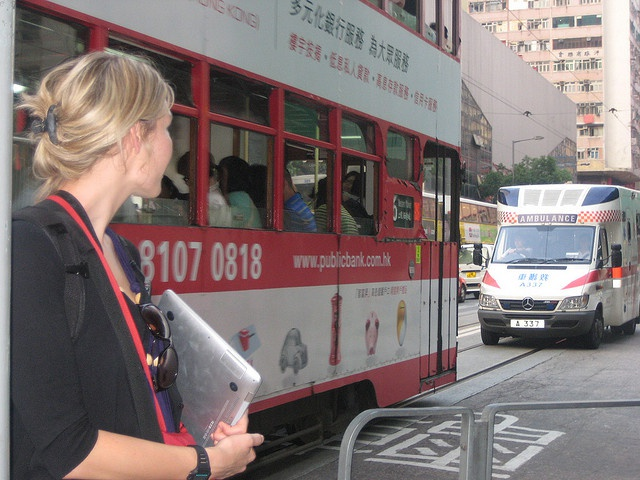Describe the objects in this image and their specific colors. I can see bus in lightgray, darkgray, black, gray, and maroon tones, people in lightgray, black, tan, and gray tones, truck in lightgray, white, darkgray, gray, and black tones, laptop in lightgray, gray, and darkgray tones, and backpack in lightgray, black, and gray tones in this image. 